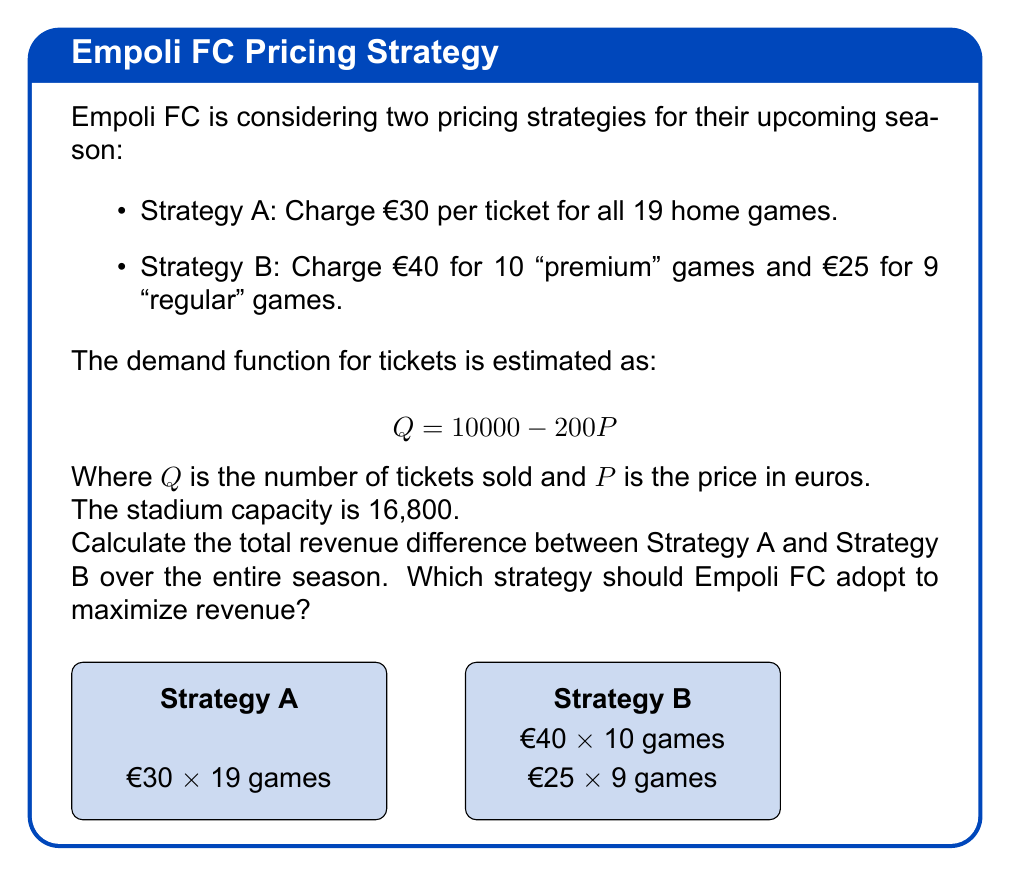Can you solve this math problem? Let's approach this step-by-step:

1) First, let's calculate the demand for each price point:

   For €30: $Q = 10000 - 200(30) = 4000$ tickets
   For €40: $Q = 10000 - 200(40) = 2000$ tickets
   For €25: $Q = 10000 - 200(25) = 5000$ tickets

2) Now, let's calculate the revenue for each strategy:

   Strategy A:
   Revenue per game = €30 * 4000 = €120,000
   Total revenue = €120,000 * 19 games = €2,280,000

   Strategy B:
   Revenue for premium games = €40 * 2000 * 10 games = €800,000
   Revenue for regular games = €25 * 5000 * 9 games = €1,125,000
   Total revenue = €800,000 + €1,125,000 = €1,925,000

3) Calculate the difference:
   €2,280,000 - €1,925,000 = €355,000

4) Strategy A generates €355,000 more revenue over the season.

5) Note: The stadium capacity (16,800) is not reached in any scenario, so it doesn't affect our calculations.
Answer: Strategy A generates €355,000 more; Empoli FC should adopt Strategy A. 